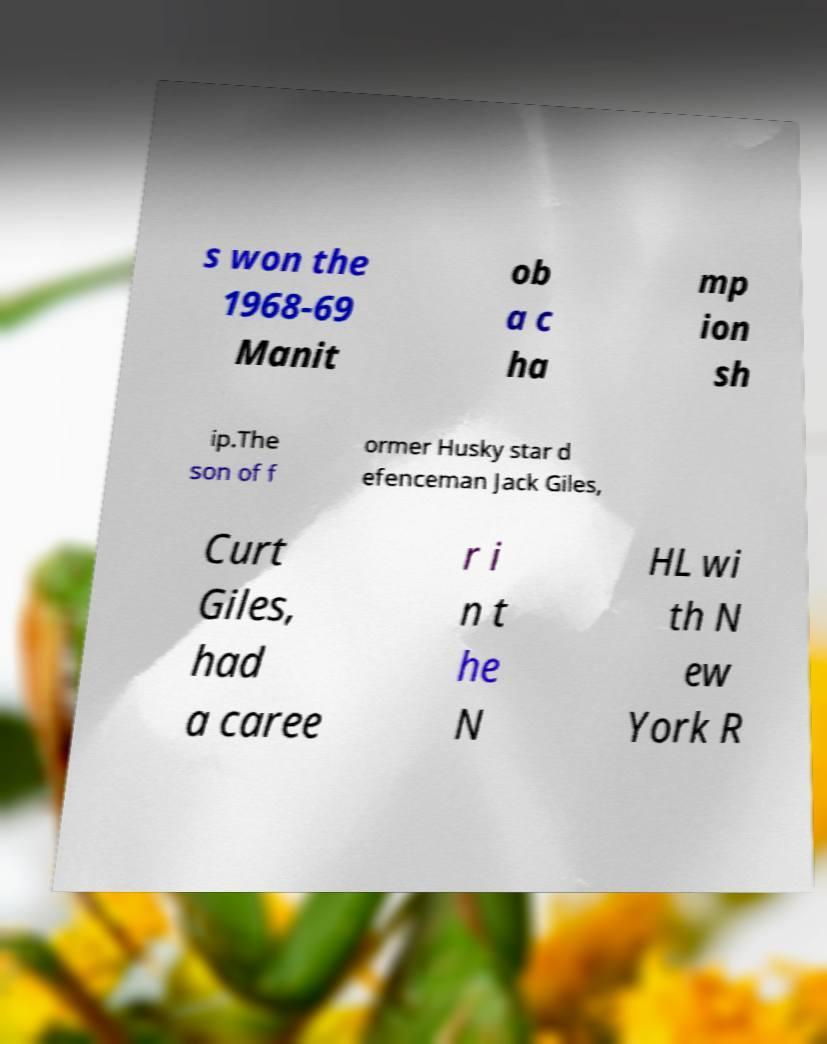Could you extract and type out the text from this image? s won the 1968-69 Manit ob a c ha mp ion sh ip.The son of f ormer Husky star d efenceman Jack Giles, Curt Giles, had a caree r i n t he N HL wi th N ew York R 